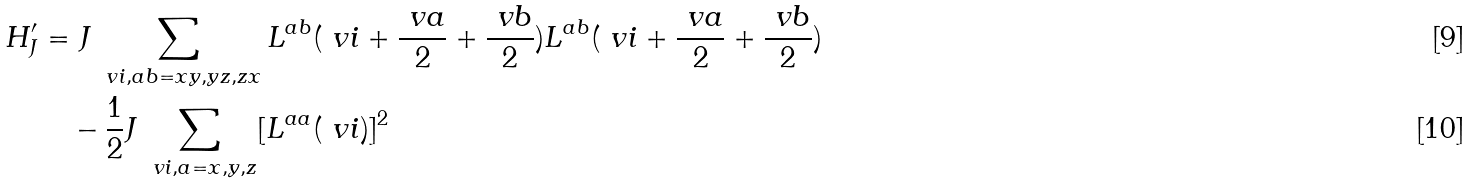<formula> <loc_0><loc_0><loc_500><loc_500>H _ { J } ^ { \prime } & = J \sum _ { \ v i , a b = x y , y z , z x } L ^ { a b } ( \ v i + \frac { \ v a } { 2 } + \frac { \ v b } { 2 } ) L ^ { a b } ( \ v i + \frac { \ v a } { 2 } + \frac { \ v b } { 2 } ) \\ & \quad - \frac { 1 } { 2 } J \sum _ { \ v i , a = x , y , z } [ L ^ { a a } ( \ v i ) ] ^ { 2 }</formula> 